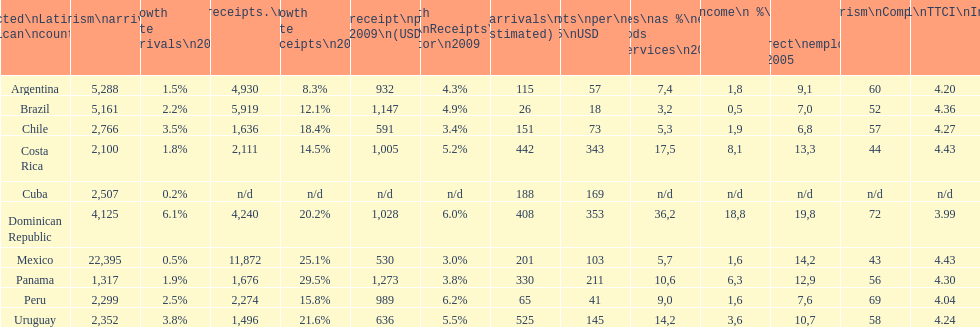Which country had the least amount of tourism income in 2003? Brazil. 